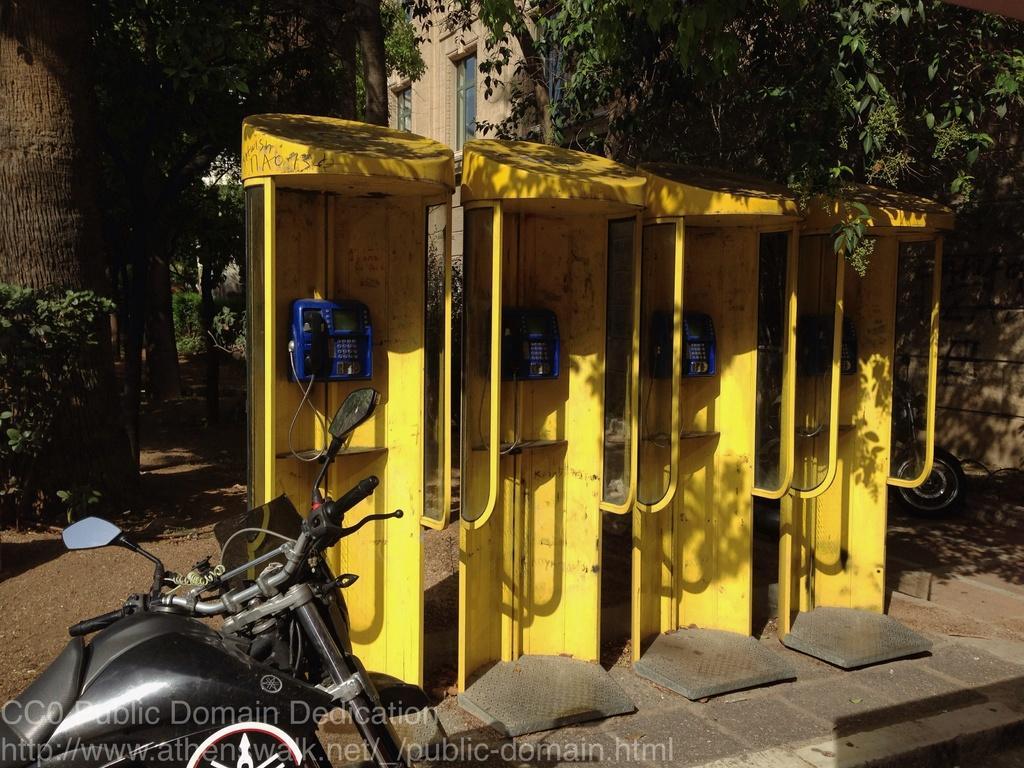How would you summarize this image in a sentence or two? In the middle of this image there are four telephone booths which are in yellow color and the telephones are in blue color. At the bottom there is a bike on the ground. In the background there are many trees and a building. In the bottom left-hand corner there is some text. 